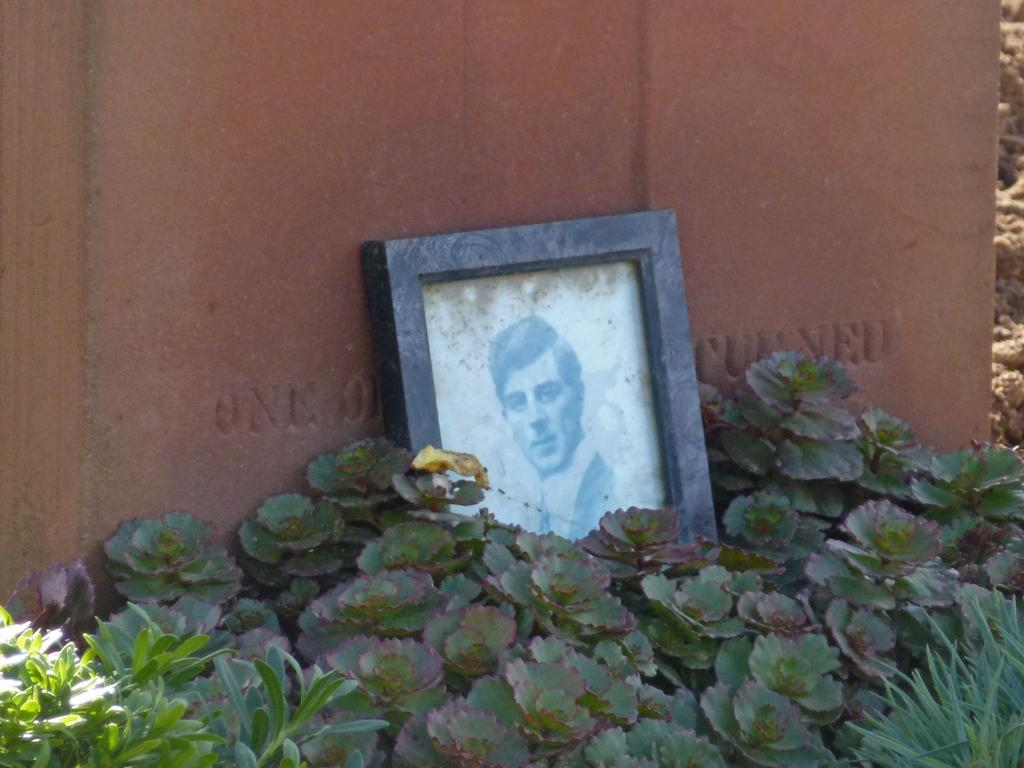What is the main object in the center of the image? There is a photo frame in the center of the image. What can be seen at the bottom of the image? There are plants at the bottom of the image. What is visible in the background of the image? There is a wall in the background of the image. What type of straw is being used to decorate the photo frame in the image? There is no straw present in the image; it features a photo frame, plants, and a wall. Can you see the toes of the person who took the photo in the image? There is no person present in the image, so their toes cannot be seen. 